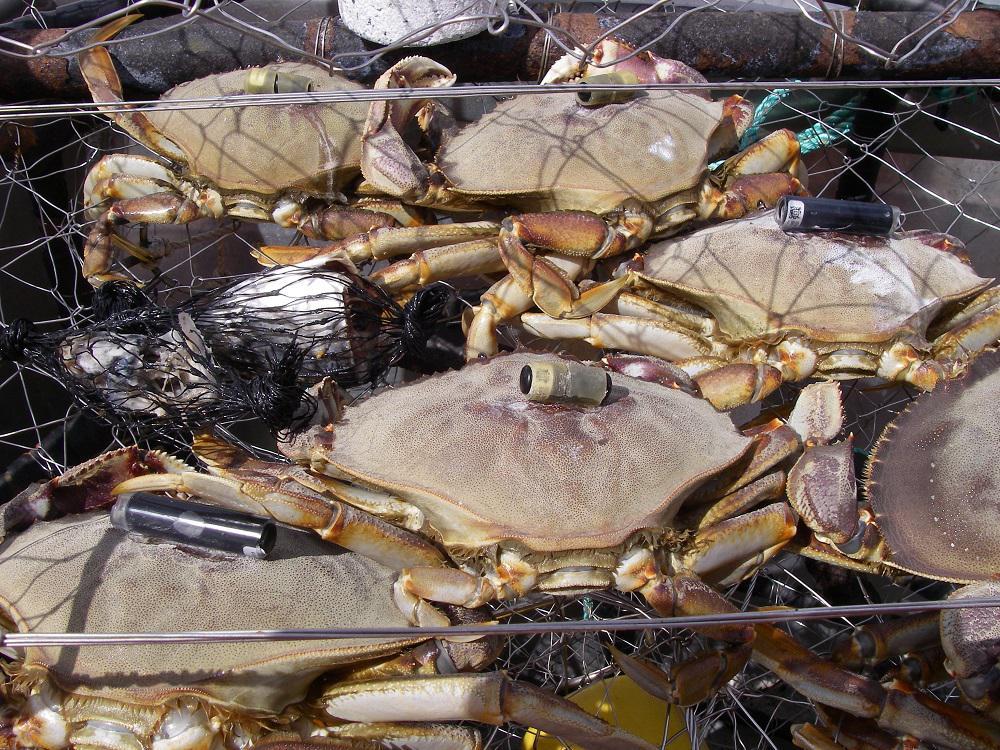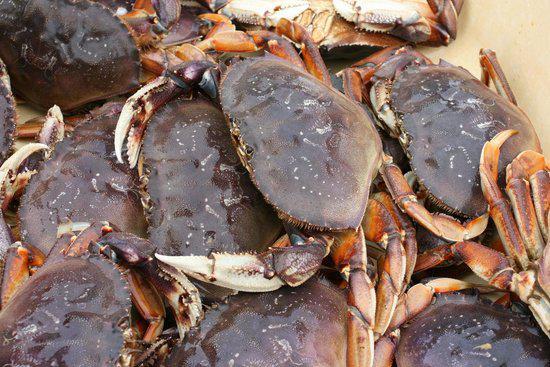The first image is the image on the left, the second image is the image on the right. Given the left and right images, does the statement "One of the images features exactly one crab." hold true? Answer yes or no. No. The first image is the image on the left, the second image is the image on the right. Analyze the images presented: Is the assertion "One image features one prominent forward-facing purple crab, and the other image features multiple crabs in a top-view." valid? Answer yes or no. No. 